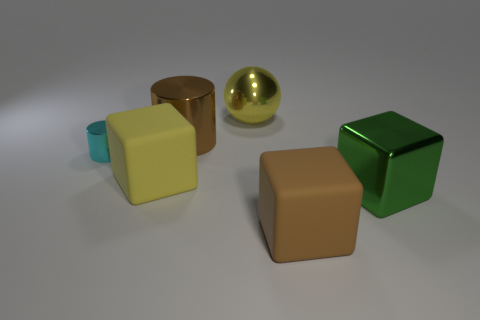Is there anything else that is the same size as the cyan metal cylinder?
Your answer should be very brief. No. What material is the large yellow object to the left of the large yellow object that is behind the large yellow cube?
Keep it short and to the point. Rubber. Does the brown metal thing have the same size as the metal object left of the big brown cylinder?
Provide a succinct answer. No. Is there a block that has the same color as the big metal ball?
Keep it short and to the point. Yes. What number of big things are either green metallic things or yellow metal balls?
Give a very brief answer. 2. How many yellow metallic things are there?
Give a very brief answer. 1. What is the material of the cylinder on the right side of the cyan cylinder?
Your answer should be very brief. Metal. There is a green cube; are there any matte blocks on the left side of it?
Offer a very short reply. Yes. Does the brown cylinder have the same size as the cyan metal thing?
Offer a very short reply. No. What number of other green things have the same material as the tiny object?
Your response must be concise. 1. 